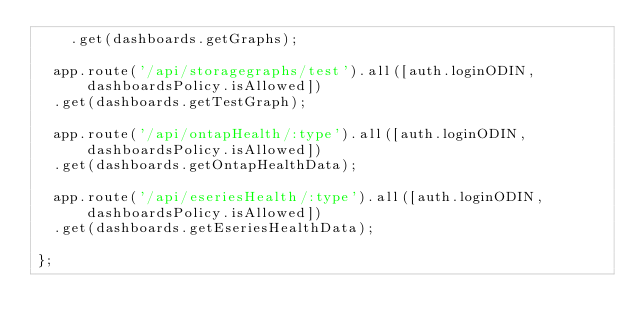Convert code to text. <code><loc_0><loc_0><loc_500><loc_500><_JavaScript_>    .get(dashboards.getGraphs);

  app.route('/api/storagegraphs/test').all([auth.loginODIN, dashboardsPolicy.isAllowed])
  .get(dashboards.getTestGraph);

  app.route('/api/ontapHealth/:type').all([auth.loginODIN, dashboardsPolicy.isAllowed])
  .get(dashboards.getOntapHealthData);

  app.route('/api/eseriesHealth/:type').all([auth.loginODIN, dashboardsPolicy.isAllowed])
  .get(dashboards.getEseriesHealthData);

};
</code> 